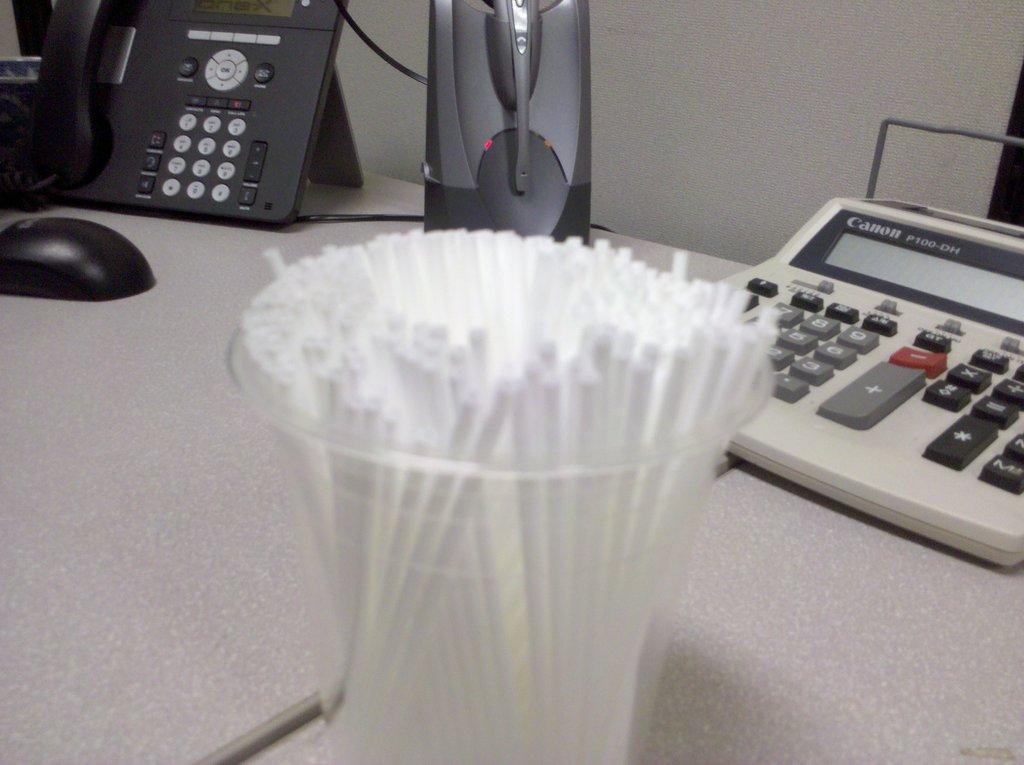<image>
Render a clear and concise summary of the photo. An old style calculator that was made by Canon is on a table. 